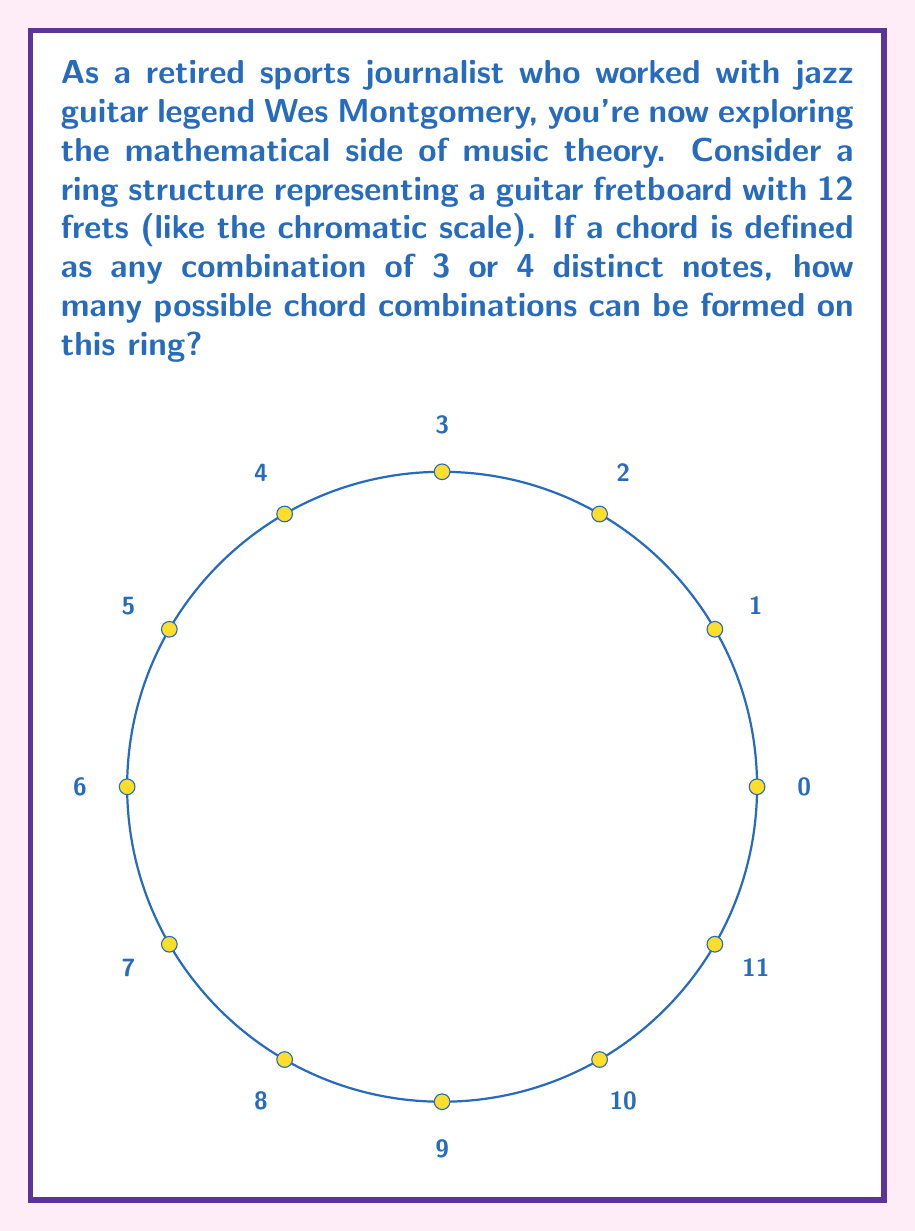Provide a solution to this math problem. Let's approach this step-by-step:

1) We have a ring with 12 elements (frets/notes).

2) We need to calculate combinations of 3 notes and 4 notes separately, then add them together.

3) For 3-note combinations:
   - This is equivalent to choosing 3 elements from 12 in a circular arrangement.
   - The formula for combinations in a circular arrangement is:
     $${n-1 \choose k-1}$$
   where $n$ is the total number of elements and $k$ is the number we're choosing.
   - So, we have: $${11 \choose 2} = \frac{11!}{2!(11-2)!} = \frac{11 \cdot 10}{2} = 55$$

4) For 4-note combinations:
   - Using the same formula: $${11 \choose 3} = \frac{11!}{3!(11-3)!} = \frac{11 \cdot 10 \cdot 9}{3 \cdot 2} = 165$$

5) Total number of chord combinations:
   $55 + 165 = 220$

Therefore, there are 220 possible chord combinations in this ring structure.
Answer: 220 